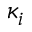Convert formula to latex. <formula><loc_0><loc_0><loc_500><loc_500>\kappa _ { i }</formula> 